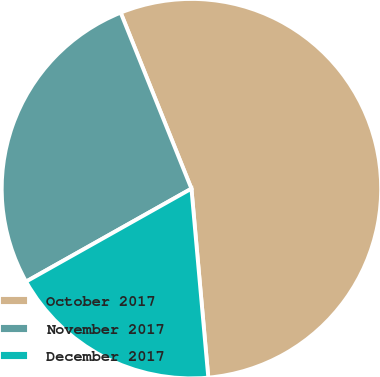<chart> <loc_0><loc_0><loc_500><loc_500><pie_chart><fcel>October 2017<fcel>November 2017<fcel>December 2017<nl><fcel>54.67%<fcel>27.07%<fcel>18.27%<nl></chart> 